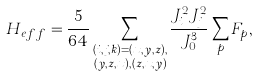Convert formula to latex. <formula><loc_0><loc_0><loc_500><loc_500>H _ { e f f } & = \frac { 5 } { 6 4 } \sum _ { \substack { ( i , j , k ) = ( x , y , z ) , \\ ( y , z , x ) , ( z , x , y ) } } \frac { J ^ { 2 } _ { i } J ^ { 2 } _ { j } } { J ^ { 3 } _ { 0 } } \sum _ { p } F _ { p } ,</formula> 